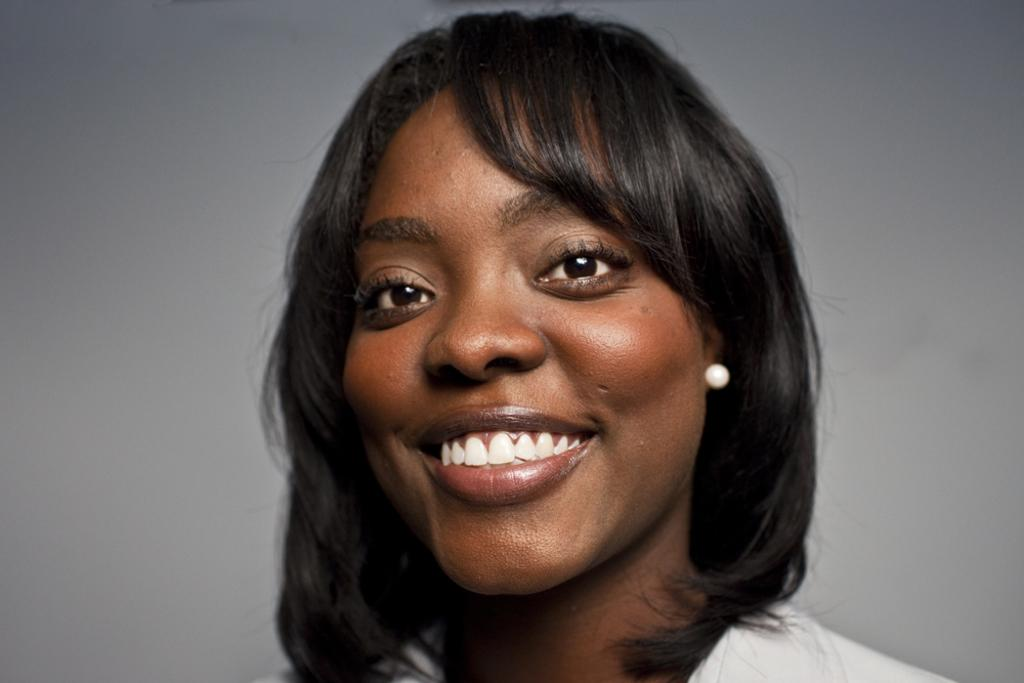Who is present in the image? There is a lady in the image. What is the lady doing in the image? The lady is smiling in the image. What can be seen in the background of the image? There is a wall in the background of the image. What type of knife is the lady holding in the image? There is no knife present in the image; the lady is simply smiling. 